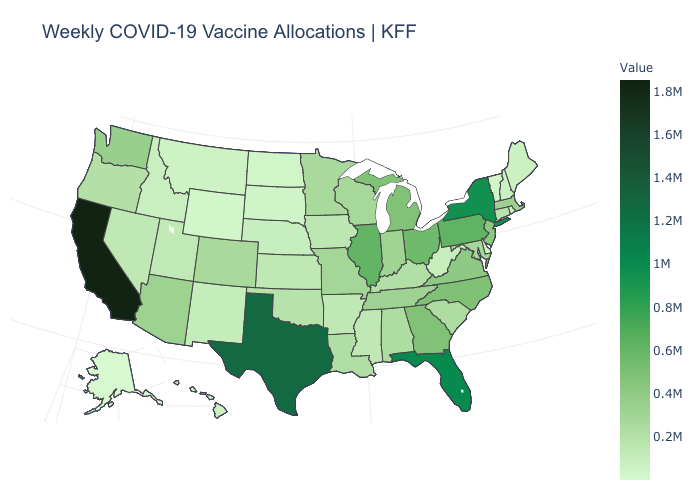Among the states that border Wyoming , which have the lowest value?
Answer briefly. South Dakota. Is the legend a continuous bar?
Short answer required. Yes. Does Mississippi have the highest value in the USA?
Keep it brief. No. Among the states that border Michigan , which have the lowest value?
Short answer required. Wisconsin. Does Delaware have the lowest value in the South?
Keep it brief. Yes. Does California have the highest value in the West?
Quick response, please. Yes. 